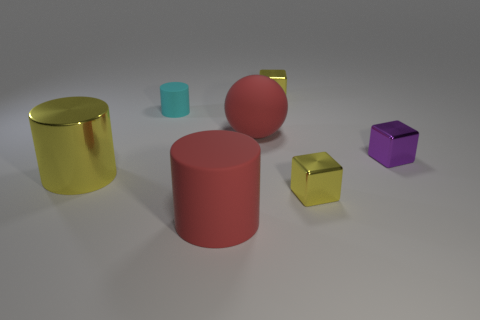There is a object that is both right of the rubber sphere and in front of the yellow metal cylinder; what shape is it?
Your answer should be very brief. Cube. Are there any large red cubes made of the same material as the purple cube?
Provide a short and direct response. No. What material is the large cylinder that is the same color as the big rubber ball?
Offer a terse response. Rubber. Is the material of the large cylinder that is right of the large yellow object the same as the big sphere behind the small purple shiny object?
Provide a short and direct response. Yes. Is the number of spheres greater than the number of tiny yellow matte spheres?
Keep it short and to the point. Yes. What color is the metallic thing that is left of the big red rubber sphere behind the yellow object left of the large red matte sphere?
Offer a terse response. Yellow. Does the block that is in front of the metallic cylinder have the same color as the small block behind the matte sphere?
Provide a short and direct response. Yes. How many metal things are in front of the yellow cube behind the rubber ball?
Offer a very short reply. 3. Are there any purple objects?
Provide a succinct answer. Yes. How many other objects are the same color as the big shiny cylinder?
Your answer should be very brief. 2. 